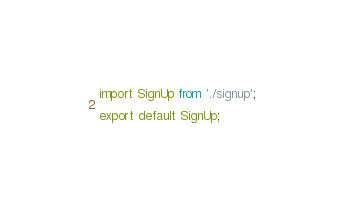Convert code to text. <code><loc_0><loc_0><loc_500><loc_500><_JavaScript_>import SignUp from './signup';

export default SignUp;
</code> 